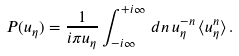<formula> <loc_0><loc_0><loc_500><loc_500>P ( u _ { \eta } ) = \frac { 1 } { i \pi u _ { \eta } } \int _ { - i \infty } ^ { + i \infty } \, d n \, u ^ { - n } _ { \eta } \, \langle u _ { \eta } ^ { n } \rangle \, .</formula> 